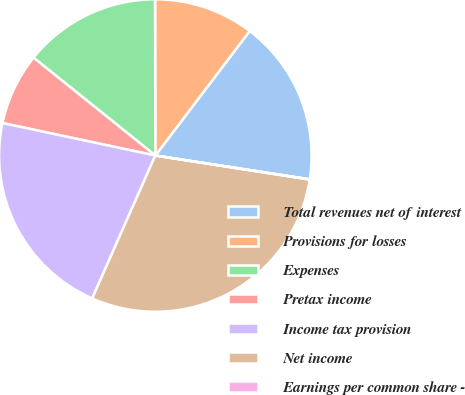Convert chart to OTSL. <chart><loc_0><loc_0><loc_500><loc_500><pie_chart><fcel>Total revenues net of interest<fcel>Provisions for losses<fcel>Expenses<fcel>Pretax income<fcel>Income tax provision<fcel>Net income<fcel>Earnings per common share -<nl><fcel>17.11%<fcel>10.35%<fcel>14.2%<fcel>7.44%<fcel>21.71%<fcel>29.16%<fcel>0.03%<nl></chart> 